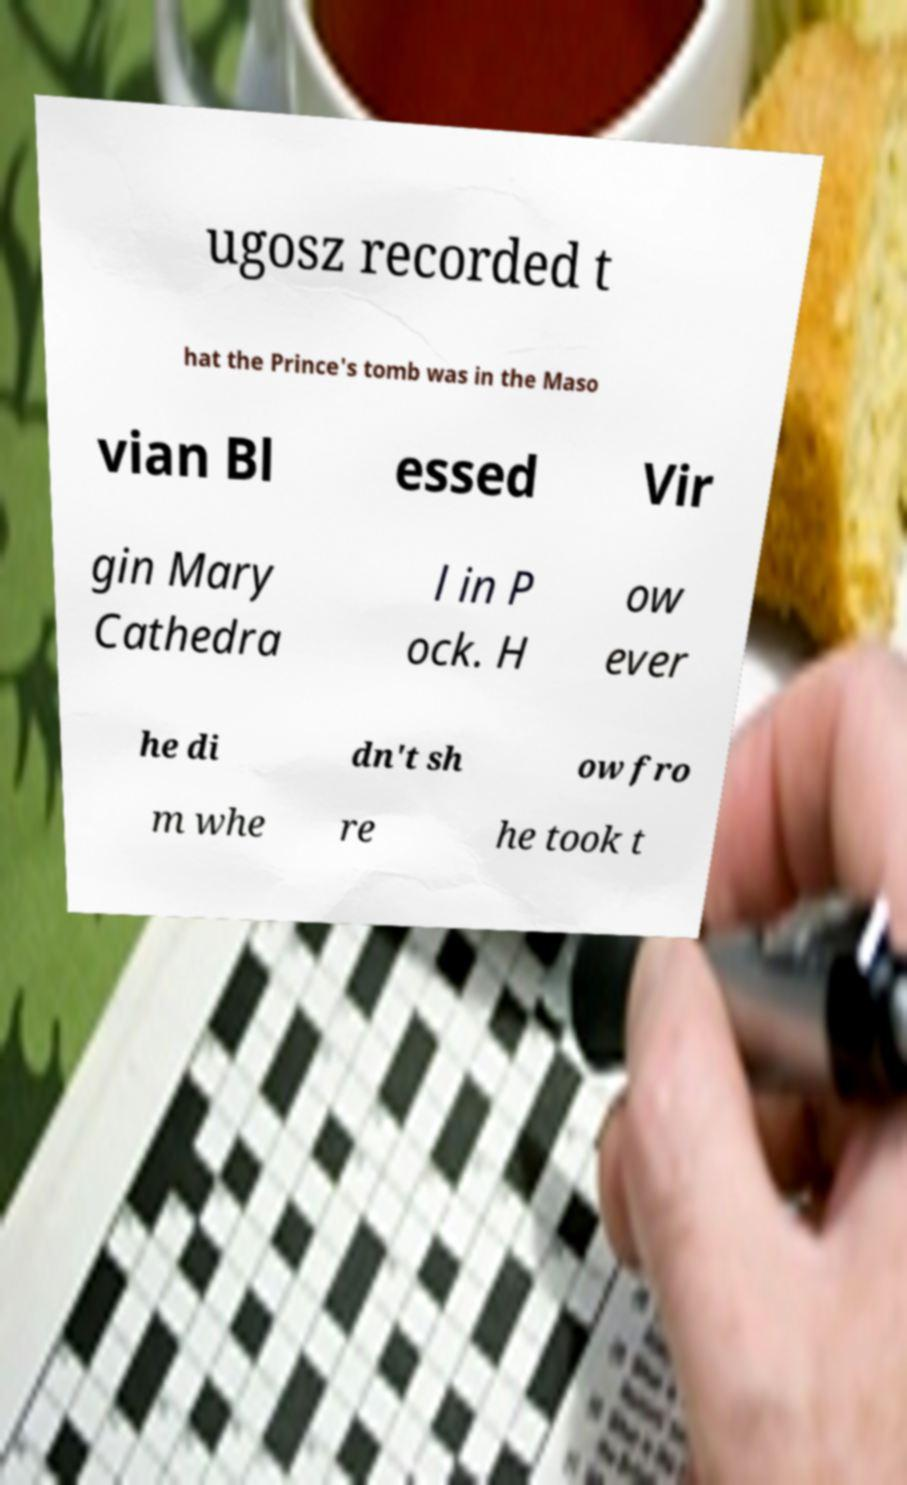There's text embedded in this image that I need extracted. Can you transcribe it verbatim? ugosz recorded t hat the Prince's tomb was in the Maso vian Bl essed Vir gin Mary Cathedra l in P ock. H ow ever he di dn't sh ow fro m whe re he took t 